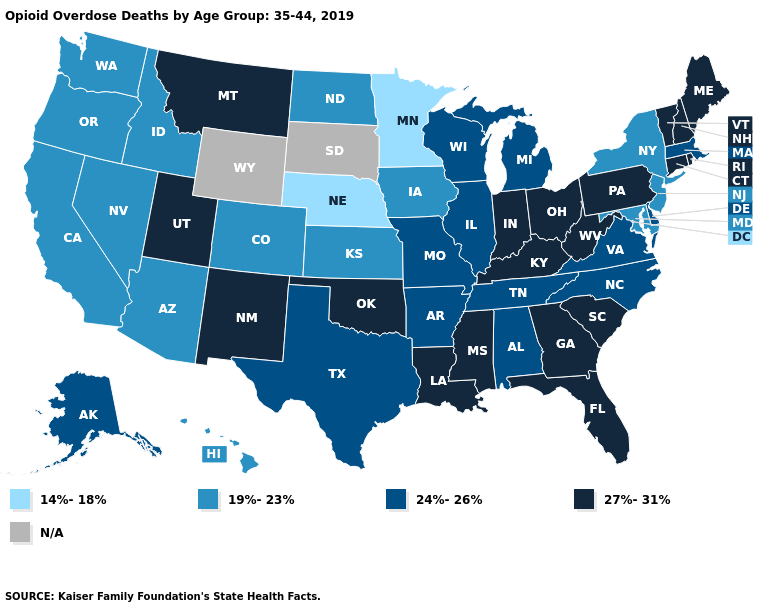Which states have the lowest value in the USA?
Keep it brief. Minnesota, Nebraska. What is the highest value in the USA?
Be succinct. 27%-31%. Which states hav the highest value in the West?
Concise answer only. Montana, New Mexico, Utah. Does Minnesota have the lowest value in the USA?
Short answer required. Yes. What is the highest value in the MidWest ?
Give a very brief answer. 27%-31%. Name the states that have a value in the range 27%-31%?
Concise answer only. Connecticut, Florida, Georgia, Indiana, Kentucky, Louisiana, Maine, Mississippi, Montana, New Hampshire, New Mexico, Ohio, Oklahoma, Pennsylvania, Rhode Island, South Carolina, Utah, Vermont, West Virginia. Name the states that have a value in the range 27%-31%?
Short answer required. Connecticut, Florida, Georgia, Indiana, Kentucky, Louisiana, Maine, Mississippi, Montana, New Hampshire, New Mexico, Ohio, Oklahoma, Pennsylvania, Rhode Island, South Carolina, Utah, Vermont, West Virginia. Name the states that have a value in the range N/A?
Quick response, please. South Dakota, Wyoming. What is the highest value in states that border Mississippi?
Be succinct. 27%-31%. Name the states that have a value in the range 27%-31%?
Keep it brief. Connecticut, Florida, Georgia, Indiana, Kentucky, Louisiana, Maine, Mississippi, Montana, New Hampshire, New Mexico, Ohio, Oklahoma, Pennsylvania, Rhode Island, South Carolina, Utah, Vermont, West Virginia. Does Minnesota have the lowest value in the MidWest?
Answer briefly. Yes. What is the highest value in states that border Illinois?
Concise answer only. 27%-31%. Does West Virginia have the highest value in the USA?
Answer briefly. Yes. What is the value of Nevada?
Short answer required. 19%-23%. 